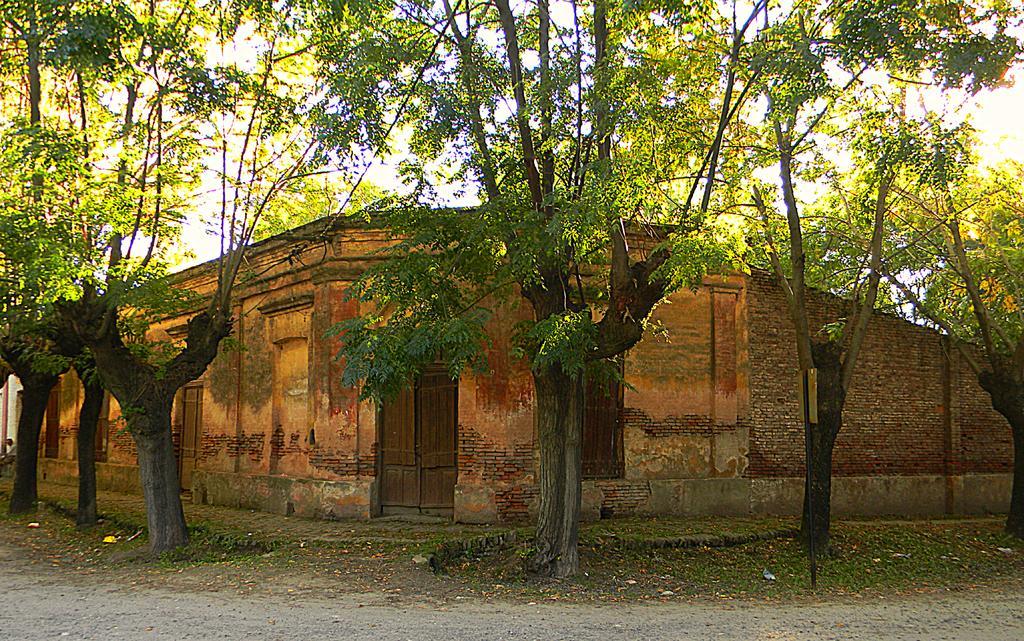Could you give a brief overview of what you see in this image? In this image I can see trees in green color, background I can see a building in brown color. In front I can see the door in brown color and the sky is in white color. 